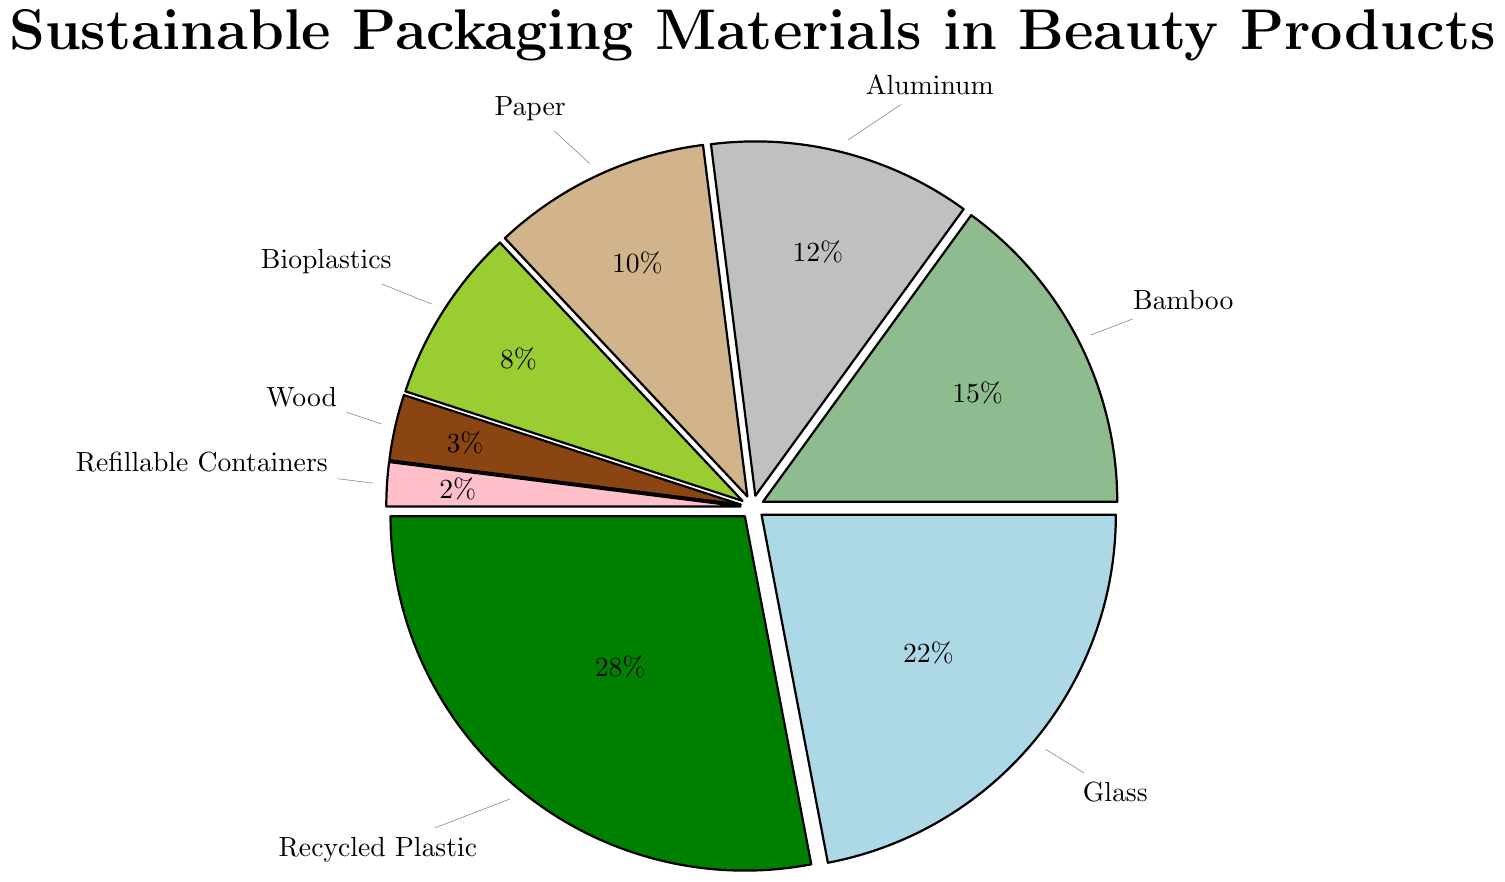Which material has the highest percentage in the distribution? To answer this, look for the segment with the largest portion of the pie chart. In this case, it’s labeled "Recycled Plastic" with 28%.
Answer: Recycled Plastic Which material has the lowest percentage in the distribution? To identify the material with the smallest portion, look for the smallest slice in the pie chart. The label indicates “Refillable Containers” with 2%.
Answer: Refillable Containers What is the combined percentage of Recycled Plastic and Glass? Add the percentages of Recycled Plastic (28%) and Glass (22%): 28% + 22% = 50%.
Answer: 50% Are there more materials with a percentage greater than 20% or less than 10%? Count the segments where percentages are greater than 20% (Recycled Plastic: 28%, Glass: 22%) which equals 2. Also, count segments less than 10% (Bioplastics: 8%, Wood: 3%, Refillable Containers: 2%) which equals 3. There are more materials with percentages less than 10%.
Answer: Less than 10% What is the difference in percentage between the largest and smallest portions? Identify the largest portion (Recycled Plastic: 28%) and the smallest portion (Refillable Containers: 2%), then subtract: 28% - 2% = 26%.
Answer: 26% What is the average percentage of Bamboo, Aluminum, and Paper/Cardboard? Sum the percentages of Bamboo (15%), Aluminum (12%), and Paper/Cardboard (10%), then divide by 3: (15% + 12% + 10%) / 3 = 37% / 3 ≈ 12.33%.
Answer: 12.33% Which two materials combined make up almost 50% of the distribution? Adding the percentages of Recycled Plastic (28%) and Glass (22%) gives 50%, which is almost exactly half.
Answer: Recycled Plastic and Glass Which material’s percentage is closest to the average percentage of all materials? First, find the average of all percentages: (28% + 22% + 15% + 12% + 10% + 8% + 3% + 2%) / 8 ≈ 12.5%. The closest percentage is Aluminum at 12%.
Answer: Aluminum Is Bamboo used more frequently than Aluminum and Paper/Cardboard combined? Compare Bamboo’s percentage (15%) with the combined percentage of Aluminum (12%) and Paper/Cardboard (10%): 12% + 10% = 22%. Bamboo is used less frequently.
Answer: No Which shade does the segment for Bioplastics have in the pie chart? Look for the segment labeled "Bioplastics" and identify its color based on the visual attributes. The segment for Bioplastics is colored green.
Answer: Green 